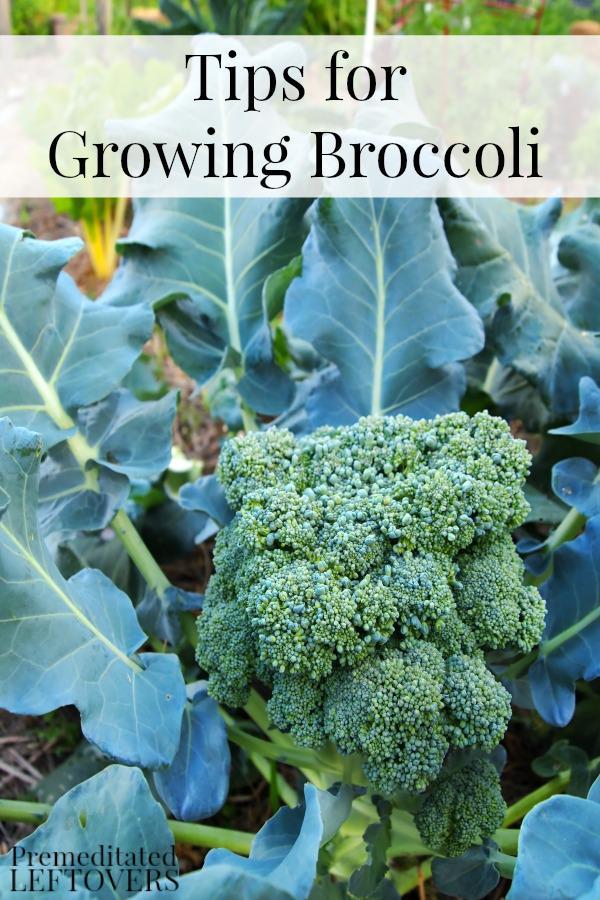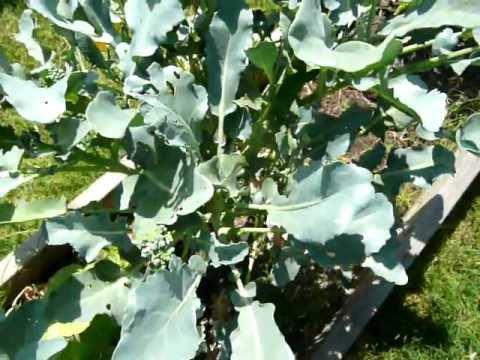The first image is the image on the left, the second image is the image on the right. Examine the images to the left and right. Is the description "There is a single bunch of brocolli in the image on the left." accurate? Answer yes or no. Yes. The first image is the image on the left, the second image is the image on the right. Analyze the images presented: Is the assertion "There is exactly one book about growing broccoli." valid? Answer yes or no. Yes. 